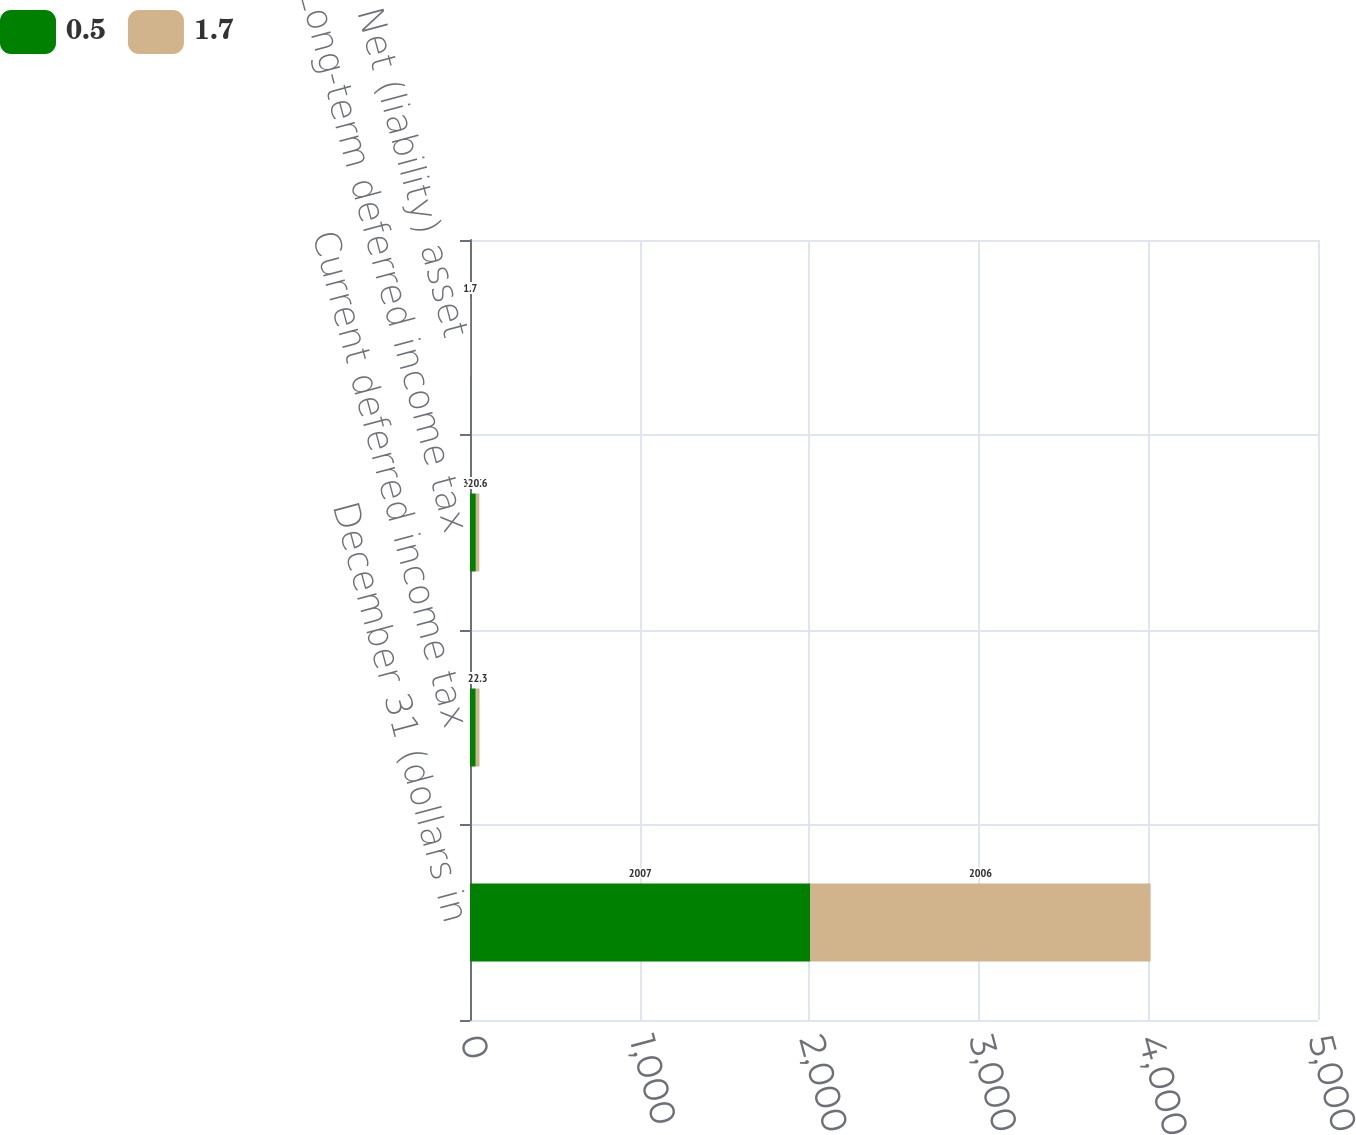<chart> <loc_0><loc_0><loc_500><loc_500><stacked_bar_chart><ecel><fcel>December 31 (dollars in<fcel>Current deferred income tax<fcel>Long-term deferred income tax<fcel>Net (liability) asset<nl><fcel>0.5<fcel>2007<fcel>34<fcel>34.5<fcel>0.5<nl><fcel>1.7<fcel>2006<fcel>22.3<fcel>20.6<fcel>1.7<nl></chart> 